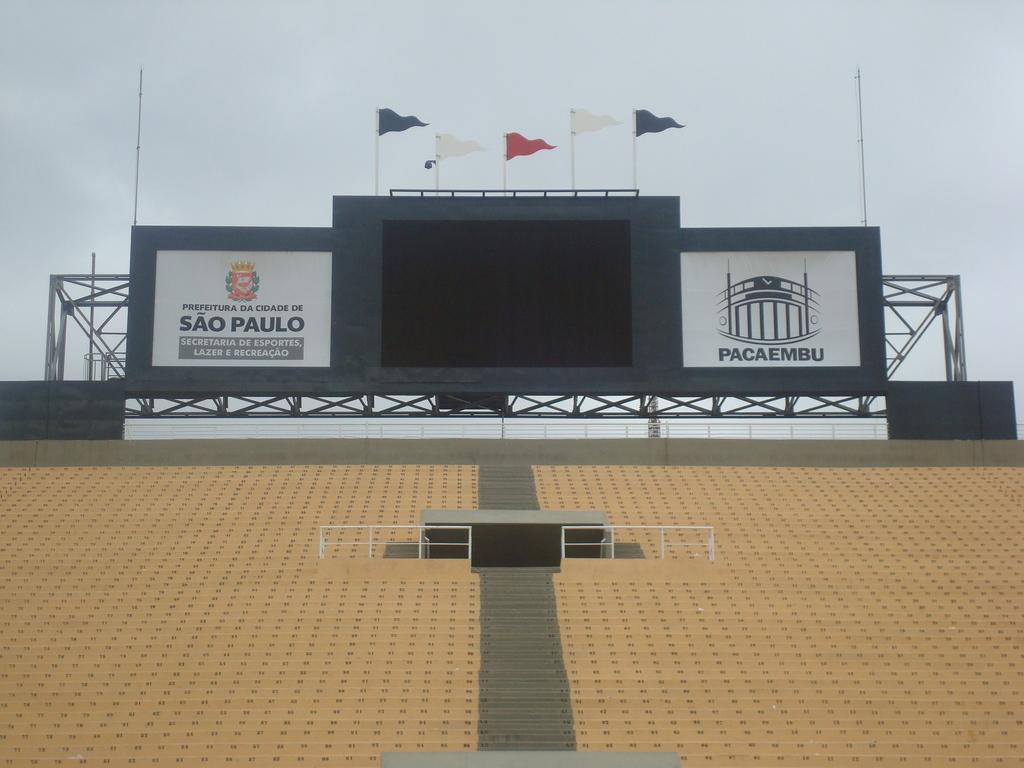Provide a one-sentence caption for the provided image. A blank scoreboard at the top of bleachers with a Sao Paulo sign to the left. 